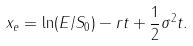Convert formula to latex. <formula><loc_0><loc_0><loc_500><loc_500>x _ { e } = \ln ( E / S _ { 0 } ) - r t + \frac { 1 } { 2 } \sigma ^ { 2 } t .</formula> 